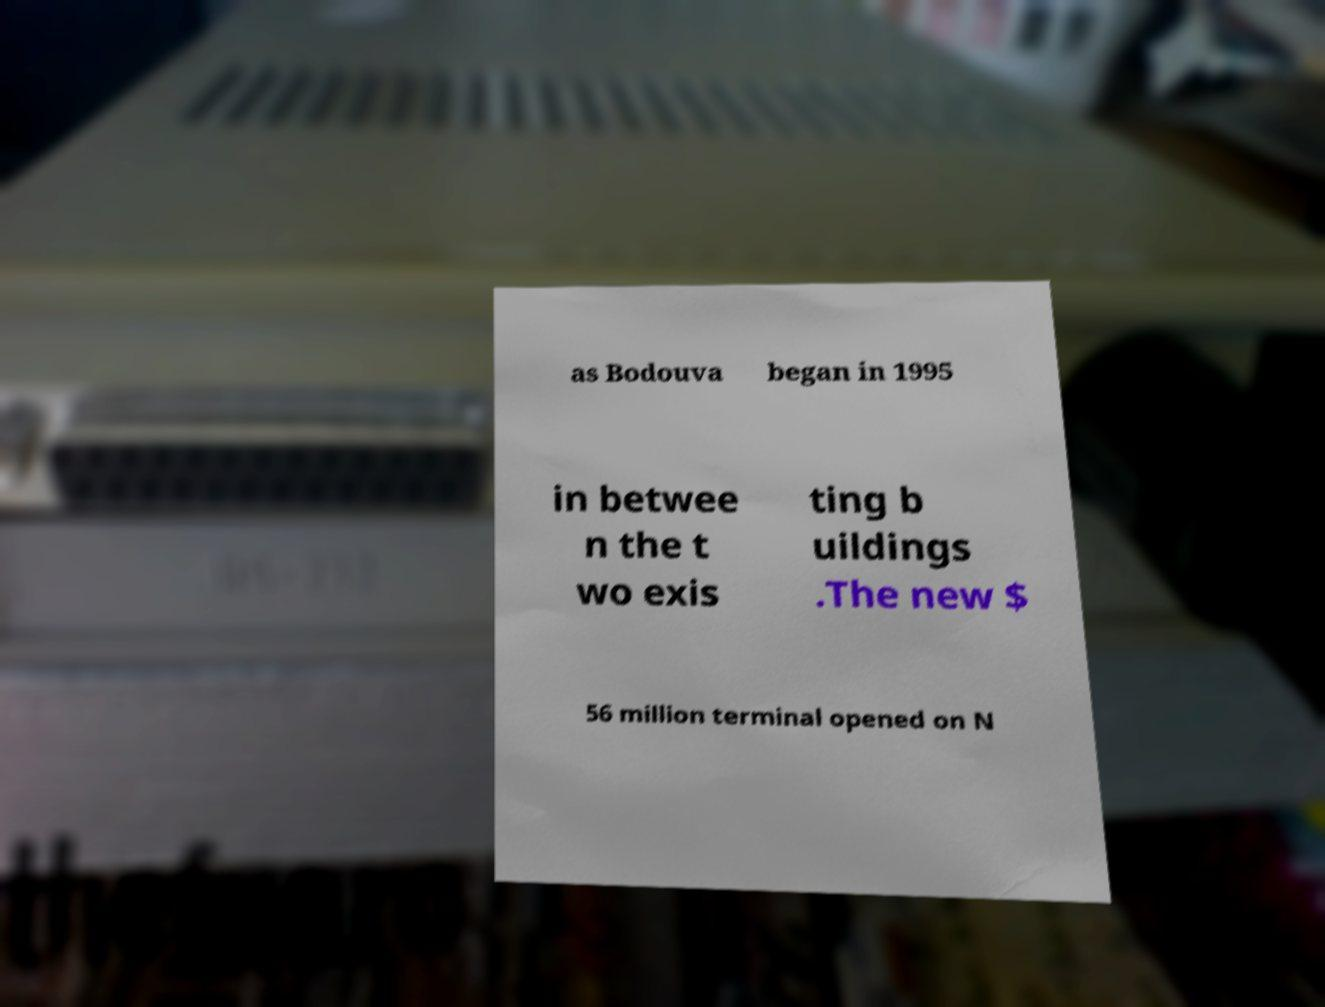Can you read and provide the text displayed in the image?This photo seems to have some interesting text. Can you extract and type it out for me? as Bodouva began in 1995 in betwee n the t wo exis ting b uildings .The new $ 56 million terminal opened on N 